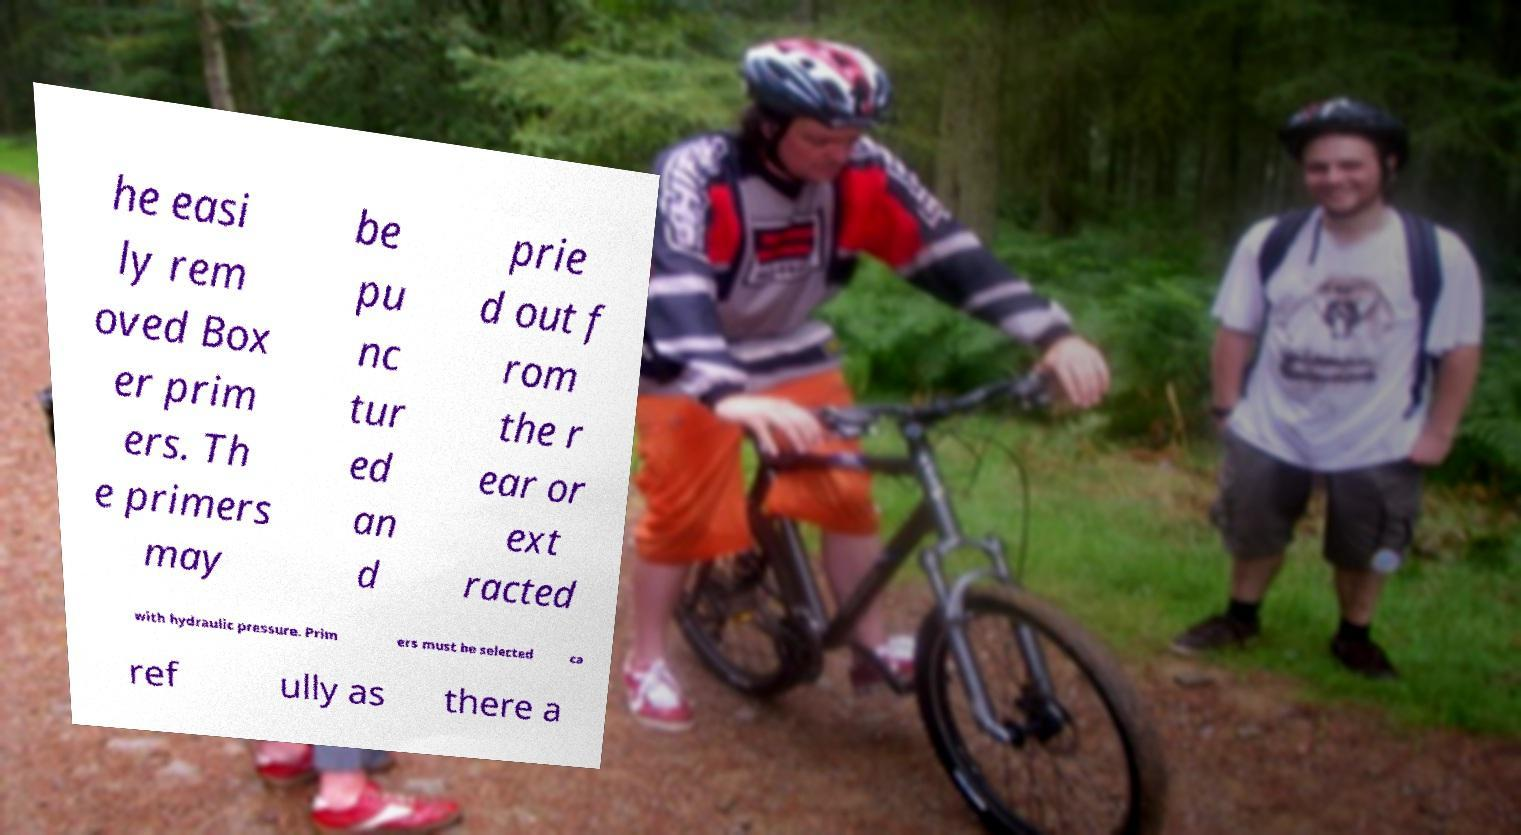Please identify and transcribe the text found in this image. he easi ly rem oved Box er prim ers. Th e primers may be pu nc tur ed an d prie d out f rom the r ear or ext racted with hydraulic pressure. Prim ers must be selected ca ref ully as there a 